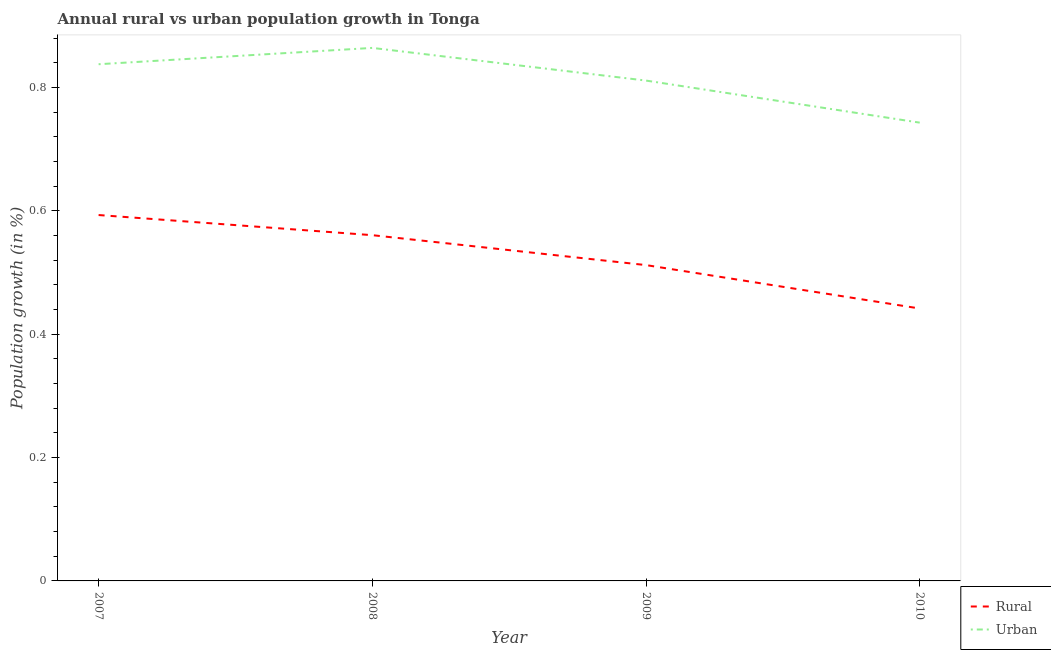What is the urban population growth in 2009?
Keep it short and to the point. 0.81. Across all years, what is the maximum urban population growth?
Keep it short and to the point. 0.86. Across all years, what is the minimum urban population growth?
Your answer should be compact. 0.74. In which year was the rural population growth maximum?
Make the answer very short. 2007. What is the total urban population growth in the graph?
Keep it short and to the point. 3.26. What is the difference between the urban population growth in 2009 and that in 2010?
Offer a terse response. 0.07. What is the difference between the rural population growth in 2009 and the urban population growth in 2007?
Provide a succinct answer. -0.33. What is the average rural population growth per year?
Offer a terse response. 0.53. In the year 2008, what is the difference between the rural population growth and urban population growth?
Provide a succinct answer. -0.3. What is the ratio of the urban population growth in 2008 to that in 2010?
Ensure brevity in your answer.  1.16. Is the rural population growth in 2007 less than that in 2009?
Make the answer very short. No. Is the difference between the urban population growth in 2009 and 2010 greater than the difference between the rural population growth in 2009 and 2010?
Your answer should be compact. No. What is the difference between the highest and the second highest rural population growth?
Make the answer very short. 0.03. What is the difference between the highest and the lowest urban population growth?
Provide a succinct answer. 0.12. In how many years, is the rural population growth greater than the average rural population growth taken over all years?
Give a very brief answer. 2. Does the rural population growth monotonically increase over the years?
Offer a very short reply. No. Is the rural population growth strictly less than the urban population growth over the years?
Your answer should be very brief. Yes. How many lines are there?
Offer a terse response. 2. How many years are there in the graph?
Make the answer very short. 4. Does the graph contain grids?
Your answer should be compact. No. How many legend labels are there?
Give a very brief answer. 2. What is the title of the graph?
Make the answer very short. Annual rural vs urban population growth in Tonga. What is the label or title of the Y-axis?
Offer a very short reply. Population growth (in %). What is the Population growth (in %) of Rural in 2007?
Provide a succinct answer. 0.59. What is the Population growth (in %) in Urban  in 2007?
Give a very brief answer. 0.84. What is the Population growth (in %) in Rural in 2008?
Ensure brevity in your answer.  0.56. What is the Population growth (in %) of Urban  in 2008?
Your answer should be compact. 0.86. What is the Population growth (in %) in Rural in 2009?
Offer a very short reply. 0.51. What is the Population growth (in %) in Urban  in 2009?
Offer a terse response. 0.81. What is the Population growth (in %) of Rural in 2010?
Keep it short and to the point. 0.44. What is the Population growth (in %) in Urban  in 2010?
Make the answer very short. 0.74. Across all years, what is the maximum Population growth (in %) of Rural?
Offer a very short reply. 0.59. Across all years, what is the maximum Population growth (in %) in Urban ?
Make the answer very short. 0.86. Across all years, what is the minimum Population growth (in %) in Rural?
Provide a succinct answer. 0.44. Across all years, what is the minimum Population growth (in %) of Urban ?
Ensure brevity in your answer.  0.74. What is the total Population growth (in %) of Rural in the graph?
Offer a terse response. 2.11. What is the total Population growth (in %) of Urban  in the graph?
Give a very brief answer. 3.26. What is the difference between the Population growth (in %) of Rural in 2007 and that in 2008?
Offer a terse response. 0.03. What is the difference between the Population growth (in %) in Urban  in 2007 and that in 2008?
Your answer should be compact. -0.03. What is the difference between the Population growth (in %) of Rural in 2007 and that in 2009?
Give a very brief answer. 0.08. What is the difference between the Population growth (in %) in Urban  in 2007 and that in 2009?
Make the answer very short. 0.03. What is the difference between the Population growth (in %) in Rural in 2007 and that in 2010?
Your response must be concise. 0.15. What is the difference between the Population growth (in %) of Urban  in 2007 and that in 2010?
Offer a very short reply. 0.09. What is the difference between the Population growth (in %) of Rural in 2008 and that in 2009?
Provide a short and direct response. 0.05. What is the difference between the Population growth (in %) of Urban  in 2008 and that in 2009?
Provide a succinct answer. 0.05. What is the difference between the Population growth (in %) in Rural in 2008 and that in 2010?
Your answer should be very brief. 0.12. What is the difference between the Population growth (in %) of Urban  in 2008 and that in 2010?
Provide a short and direct response. 0.12. What is the difference between the Population growth (in %) in Rural in 2009 and that in 2010?
Give a very brief answer. 0.07. What is the difference between the Population growth (in %) of Urban  in 2009 and that in 2010?
Offer a terse response. 0.07. What is the difference between the Population growth (in %) of Rural in 2007 and the Population growth (in %) of Urban  in 2008?
Offer a terse response. -0.27. What is the difference between the Population growth (in %) of Rural in 2007 and the Population growth (in %) of Urban  in 2009?
Make the answer very short. -0.22. What is the difference between the Population growth (in %) of Rural in 2007 and the Population growth (in %) of Urban  in 2010?
Ensure brevity in your answer.  -0.15. What is the difference between the Population growth (in %) of Rural in 2008 and the Population growth (in %) of Urban  in 2009?
Offer a very short reply. -0.25. What is the difference between the Population growth (in %) of Rural in 2008 and the Population growth (in %) of Urban  in 2010?
Your response must be concise. -0.18. What is the difference between the Population growth (in %) in Rural in 2009 and the Population growth (in %) in Urban  in 2010?
Make the answer very short. -0.23. What is the average Population growth (in %) in Rural per year?
Ensure brevity in your answer.  0.53. What is the average Population growth (in %) of Urban  per year?
Ensure brevity in your answer.  0.81. In the year 2007, what is the difference between the Population growth (in %) in Rural and Population growth (in %) in Urban ?
Offer a terse response. -0.24. In the year 2008, what is the difference between the Population growth (in %) of Rural and Population growth (in %) of Urban ?
Ensure brevity in your answer.  -0.3. In the year 2009, what is the difference between the Population growth (in %) in Rural and Population growth (in %) in Urban ?
Ensure brevity in your answer.  -0.3. In the year 2010, what is the difference between the Population growth (in %) of Rural and Population growth (in %) of Urban ?
Provide a short and direct response. -0.3. What is the ratio of the Population growth (in %) of Rural in 2007 to that in 2008?
Provide a succinct answer. 1.06. What is the ratio of the Population growth (in %) of Urban  in 2007 to that in 2008?
Give a very brief answer. 0.97. What is the ratio of the Population growth (in %) of Rural in 2007 to that in 2009?
Ensure brevity in your answer.  1.16. What is the ratio of the Population growth (in %) of Urban  in 2007 to that in 2009?
Your answer should be very brief. 1.03. What is the ratio of the Population growth (in %) of Rural in 2007 to that in 2010?
Offer a terse response. 1.34. What is the ratio of the Population growth (in %) in Urban  in 2007 to that in 2010?
Ensure brevity in your answer.  1.13. What is the ratio of the Population growth (in %) of Rural in 2008 to that in 2009?
Give a very brief answer. 1.09. What is the ratio of the Population growth (in %) in Urban  in 2008 to that in 2009?
Ensure brevity in your answer.  1.07. What is the ratio of the Population growth (in %) in Rural in 2008 to that in 2010?
Offer a terse response. 1.27. What is the ratio of the Population growth (in %) of Urban  in 2008 to that in 2010?
Provide a short and direct response. 1.16. What is the ratio of the Population growth (in %) in Rural in 2009 to that in 2010?
Your answer should be very brief. 1.16. What is the ratio of the Population growth (in %) of Urban  in 2009 to that in 2010?
Your answer should be very brief. 1.09. What is the difference between the highest and the second highest Population growth (in %) in Rural?
Provide a short and direct response. 0.03. What is the difference between the highest and the second highest Population growth (in %) in Urban ?
Offer a terse response. 0.03. What is the difference between the highest and the lowest Population growth (in %) in Rural?
Provide a short and direct response. 0.15. What is the difference between the highest and the lowest Population growth (in %) of Urban ?
Your answer should be compact. 0.12. 